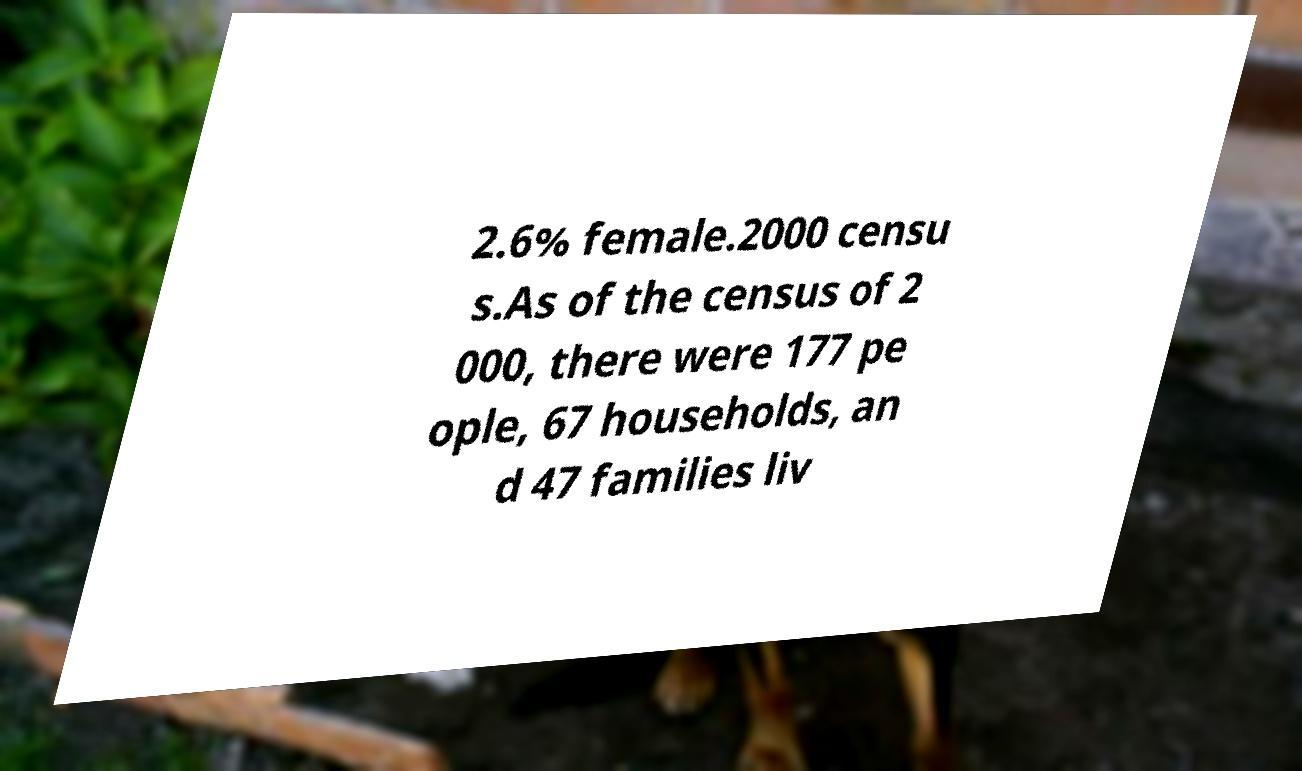I need the written content from this picture converted into text. Can you do that? 2.6% female.2000 censu s.As of the census of 2 000, there were 177 pe ople, 67 households, an d 47 families liv 